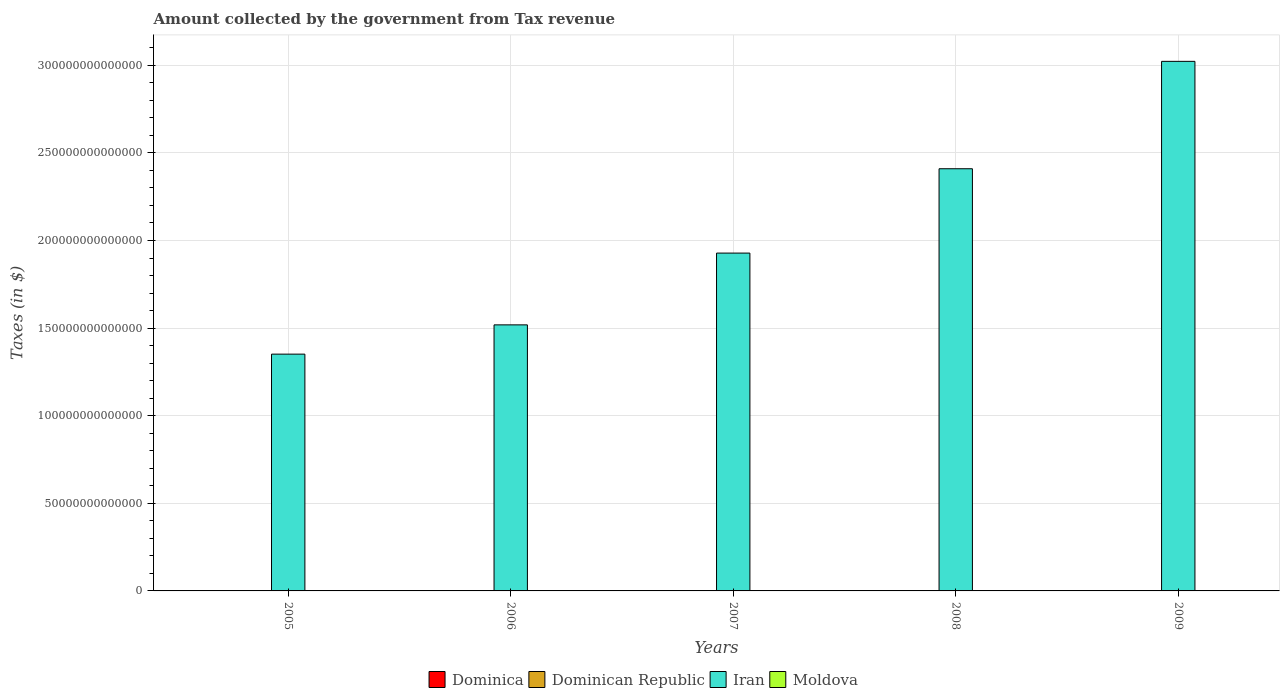How many different coloured bars are there?
Give a very brief answer. 4. Are the number of bars per tick equal to the number of legend labels?
Make the answer very short. Yes. How many bars are there on the 3rd tick from the left?
Offer a very short reply. 4. In how many cases, is the number of bars for a given year not equal to the number of legend labels?
Provide a succinct answer. 0. What is the amount collected by the government from tax revenue in Dominica in 2008?
Keep it short and to the point. 3.07e+08. Across all years, what is the maximum amount collected by the government from tax revenue in Dominica?
Provide a succinct answer. 3.21e+08. Across all years, what is the minimum amount collected by the government from tax revenue in Moldova?
Your answer should be very brief. 6.96e+09. In which year was the amount collected by the government from tax revenue in Dominica minimum?
Your answer should be compact. 2005. What is the total amount collected by the government from tax revenue in Dominica in the graph?
Your answer should be very brief. 1.39e+09. What is the difference between the amount collected by the government from tax revenue in Moldova in 2006 and that in 2007?
Offer a terse response. -2.23e+09. What is the difference between the amount collected by the government from tax revenue in Dominica in 2008 and the amount collected by the government from tax revenue in Moldova in 2009?
Provide a succinct answer. -1.04e+1. What is the average amount collected by the government from tax revenue in Dominica per year?
Give a very brief answer. 2.78e+08. In the year 2007, what is the difference between the amount collected by the government from tax revenue in Dominican Republic and amount collected by the government from tax revenue in Dominica?
Ensure brevity in your answer.  2.17e+11. In how many years, is the amount collected by the government from tax revenue in Moldova greater than 300000000000000 $?
Provide a short and direct response. 0. What is the ratio of the amount collected by the government from tax revenue in Dominican Republic in 2006 to that in 2009?
Your response must be concise. 0.8. What is the difference between the highest and the second highest amount collected by the government from tax revenue in Moldova?
Make the answer very short. 1.88e+09. What is the difference between the highest and the lowest amount collected by the government from tax revenue in Iran?
Offer a very short reply. 1.67e+14. What does the 4th bar from the left in 2008 represents?
Your answer should be compact. Moldova. What does the 3rd bar from the right in 2005 represents?
Offer a very short reply. Dominican Republic. How many bars are there?
Offer a very short reply. 20. What is the difference between two consecutive major ticks on the Y-axis?
Ensure brevity in your answer.  5.00e+13. Does the graph contain any zero values?
Ensure brevity in your answer.  No. Does the graph contain grids?
Give a very brief answer. Yes. Where does the legend appear in the graph?
Provide a succinct answer. Bottom center. What is the title of the graph?
Ensure brevity in your answer.  Amount collected by the government from Tax revenue. What is the label or title of the Y-axis?
Offer a very short reply. Taxes (in $). What is the Taxes (in $) in Dominica in 2005?
Your answer should be compact. 2.29e+08. What is the Taxes (in $) in Dominican Republic in 2005?
Provide a short and direct response. 1.48e+11. What is the Taxes (in $) in Iran in 2005?
Offer a terse response. 1.35e+14. What is the Taxes (in $) of Moldova in 2005?
Ensure brevity in your answer.  6.96e+09. What is the Taxes (in $) in Dominica in 2006?
Ensure brevity in your answer.  2.48e+08. What is the Taxes (in $) in Dominican Republic in 2006?
Keep it short and to the point. 1.77e+11. What is the Taxes (in $) in Iran in 2006?
Ensure brevity in your answer.  1.52e+14. What is the Taxes (in $) in Moldova in 2006?
Keep it short and to the point. 8.76e+09. What is the Taxes (in $) in Dominica in 2007?
Keep it short and to the point. 2.86e+08. What is the Taxes (in $) of Dominican Republic in 2007?
Offer a terse response. 2.17e+11. What is the Taxes (in $) in Iran in 2007?
Offer a very short reply. 1.93e+14. What is the Taxes (in $) of Moldova in 2007?
Offer a very short reply. 1.10e+1. What is the Taxes (in $) in Dominica in 2008?
Give a very brief answer. 3.07e+08. What is the Taxes (in $) of Dominican Republic in 2008?
Offer a very short reply. 2.35e+11. What is the Taxes (in $) in Iran in 2008?
Offer a very short reply. 2.41e+14. What is the Taxes (in $) of Moldova in 2008?
Offer a terse response. 1.29e+1. What is the Taxes (in $) in Dominica in 2009?
Keep it short and to the point. 3.21e+08. What is the Taxes (in $) in Dominican Republic in 2009?
Your answer should be compact. 2.19e+11. What is the Taxes (in $) of Iran in 2009?
Keep it short and to the point. 3.02e+14. What is the Taxes (in $) of Moldova in 2009?
Offer a terse response. 1.07e+1. Across all years, what is the maximum Taxes (in $) of Dominica?
Offer a terse response. 3.21e+08. Across all years, what is the maximum Taxes (in $) in Dominican Republic?
Ensure brevity in your answer.  2.35e+11. Across all years, what is the maximum Taxes (in $) in Iran?
Your answer should be very brief. 3.02e+14. Across all years, what is the maximum Taxes (in $) in Moldova?
Give a very brief answer. 1.29e+1. Across all years, what is the minimum Taxes (in $) of Dominica?
Your response must be concise. 2.29e+08. Across all years, what is the minimum Taxes (in $) of Dominican Republic?
Provide a succinct answer. 1.48e+11. Across all years, what is the minimum Taxes (in $) in Iran?
Offer a terse response. 1.35e+14. Across all years, what is the minimum Taxes (in $) in Moldova?
Your response must be concise. 6.96e+09. What is the total Taxes (in $) in Dominica in the graph?
Give a very brief answer. 1.39e+09. What is the total Taxes (in $) of Dominican Republic in the graph?
Provide a short and direct response. 9.97e+11. What is the total Taxes (in $) in Iran in the graph?
Offer a very short reply. 1.02e+15. What is the total Taxes (in $) of Moldova in the graph?
Offer a terse response. 5.03e+1. What is the difference between the Taxes (in $) of Dominica in 2005 and that in 2006?
Give a very brief answer. -1.86e+07. What is the difference between the Taxes (in $) in Dominican Republic in 2005 and that in 2006?
Ensure brevity in your answer.  -2.81e+1. What is the difference between the Taxes (in $) of Iran in 2005 and that in 2006?
Offer a terse response. -1.67e+13. What is the difference between the Taxes (in $) of Moldova in 2005 and that in 2006?
Offer a terse response. -1.80e+09. What is the difference between the Taxes (in $) of Dominica in 2005 and that in 2007?
Your answer should be very brief. -5.62e+07. What is the difference between the Taxes (in $) in Dominican Republic in 2005 and that in 2007?
Ensure brevity in your answer.  -6.87e+1. What is the difference between the Taxes (in $) of Iran in 2005 and that in 2007?
Give a very brief answer. -5.77e+13. What is the difference between the Taxes (in $) in Moldova in 2005 and that in 2007?
Your answer should be compact. -4.03e+09. What is the difference between the Taxes (in $) in Dominica in 2005 and that in 2008?
Your response must be concise. -7.81e+07. What is the difference between the Taxes (in $) in Dominican Republic in 2005 and that in 2008?
Provide a succinct answer. -8.69e+1. What is the difference between the Taxes (in $) of Iran in 2005 and that in 2008?
Give a very brief answer. -1.06e+14. What is the difference between the Taxes (in $) in Moldova in 2005 and that in 2008?
Provide a succinct answer. -5.90e+09. What is the difference between the Taxes (in $) in Dominica in 2005 and that in 2009?
Offer a terse response. -9.13e+07. What is the difference between the Taxes (in $) of Dominican Republic in 2005 and that in 2009?
Offer a very short reply. -7.10e+1. What is the difference between the Taxes (in $) of Iran in 2005 and that in 2009?
Offer a terse response. -1.67e+14. What is the difference between the Taxes (in $) in Moldova in 2005 and that in 2009?
Ensure brevity in your answer.  -3.73e+09. What is the difference between the Taxes (in $) of Dominica in 2006 and that in 2007?
Your response must be concise. -3.76e+07. What is the difference between the Taxes (in $) of Dominican Republic in 2006 and that in 2007?
Provide a succinct answer. -4.06e+1. What is the difference between the Taxes (in $) of Iran in 2006 and that in 2007?
Keep it short and to the point. -4.10e+13. What is the difference between the Taxes (in $) of Moldova in 2006 and that in 2007?
Your answer should be compact. -2.23e+09. What is the difference between the Taxes (in $) in Dominica in 2006 and that in 2008?
Provide a short and direct response. -5.95e+07. What is the difference between the Taxes (in $) in Dominican Republic in 2006 and that in 2008?
Your answer should be compact. -5.88e+1. What is the difference between the Taxes (in $) of Iran in 2006 and that in 2008?
Your answer should be very brief. -8.91e+13. What is the difference between the Taxes (in $) in Moldova in 2006 and that in 2008?
Your answer should be compact. -4.11e+09. What is the difference between the Taxes (in $) in Dominica in 2006 and that in 2009?
Your answer should be very brief. -7.27e+07. What is the difference between the Taxes (in $) in Dominican Republic in 2006 and that in 2009?
Make the answer very short. -4.28e+1. What is the difference between the Taxes (in $) of Iran in 2006 and that in 2009?
Your response must be concise. -1.50e+14. What is the difference between the Taxes (in $) in Moldova in 2006 and that in 2009?
Your answer should be very brief. -1.93e+09. What is the difference between the Taxes (in $) of Dominica in 2007 and that in 2008?
Offer a terse response. -2.19e+07. What is the difference between the Taxes (in $) in Dominican Republic in 2007 and that in 2008?
Provide a succinct answer. -1.82e+1. What is the difference between the Taxes (in $) in Iran in 2007 and that in 2008?
Your answer should be very brief. -4.81e+13. What is the difference between the Taxes (in $) in Moldova in 2007 and that in 2008?
Offer a terse response. -1.88e+09. What is the difference between the Taxes (in $) of Dominica in 2007 and that in 2009?
Give a very brief answer. -3.51e+07. What is the difference between the Taxes (in $) in Dominican Republic in 2007 and that in 2009?
Offer a very short reply. -2.26e+09. What is the difference between the Taxes (in $) of Iran in 2007 and that in 2009?
Provide a short and direct response. -1.09e+14. What is the difference between the Taxes (in $) in Moldova in 2007 and that in 2009?
Offer a terse response. 3.02e+08. What is the difference between the Taxes (in $) of Dominica in 2008 and that in 2009?
Keep it short and to the point. -1.32e+07. What is the difference between the Taxes (in $) of Dominican Republic in 2008 and that in 2009?
Your response must be concise. 1.59e+1. What is the difference between the Taxes (in $) of Iran in 2008 and that in 2009?
Keep it short and to the point. -6.13e+13. What is the difference between the Taxes (in $) of Moldova in 2008 and that in 2009?
Your answer should be very brief. 2.18e+09. What is the difference between the Taxes (in $) in Dominica in 2005 and the Taxes (in $) in Dominican Republic in 2006?
Offer a very short reply. -1.76e+11. What is the difference between the Taxes (in $) of Dominica in 2005 and the Taxes (in $) of Iran in 2006?
Keep it short and to the point. -1.52e+14. What is the difference between the Taxes (in $) of Dominica in 2005 and the Taxes (in $) of Moldova in 2006?
Keep it short and to the point. -8.53e+09. What is the difference between the Taxes (in $) of Dominican Republic in 2005 and the Taxes (in $) of Iran in 2006?
Provide a succinct answer. -1.52e+14. What is the difference between the Taxes (in $) in Dominican Republic in 2005 and the Taxes (in $) in Moldova in 2006?
Ensure brevity in your answer.  1.40e+11. What is the difference between the Taxes (in $) of Iran in 2005 and the Taxes (in $) of Moldova in 2006?
Your answer should be very brief. 1.35e+14. What is the difference between the Taxes (in $) in Dominica in 2005 and the Taxes (in $) in Dominican Republic in 2007?
Make the answer very short. -2.17e+11. What is the difference between the Taxes (in $) of Dominica in 2005 and the Taxes (in $) of Iran in 2007?
Your answer should be very brief. -1.93e+14. What is the difference between the Taxes (in $) of Dominica in 2005 and the Taxes (in $) of Moldova in 2007?
Provide a succinct answer. -1.08e+1. What is the difference between the Taxes (in $) of Dominican Republic in 2005 and the Taxes (in $) of Iran in 2007?
Your answer should be compact. -1.93e+14. What is the difference between the Taxes (in $) of Dominican Republic in 2005 and the Taxes (in $) of Moldova in 2007?
Offer a very short reply. 1.37e+11. What is the difference between the Taxes (in $) of Iran in 2005 and the Taxes (in $) of Moldova in 2007?
Ensure brevity in your answer.  1.35e+14. What is the difference between the Taxes (in $) of Dominica in 2005 and the Taxes (in $) of Dominican Republic in 2008?
Keep it short and to the point. -2.35e+11. What is the difference between the Taxes (in $) of Dominica in 2005 and the Taxes (in $) of Iran in 2008?
Your response must be concise. -2.41e+14. What is the difference between the Taxes (in $) in Dominica in 2005 and the Taxes (in $) in Moldova in 2008?
Your answer should be very brief. -1.26e+1. What is the difference between the Taxes (in $) in Dominican Republic in 2005 and the Taxes (in $) in Iran in 2008?
Your answer should be compact. -2.41e+14. What is the difference between the Taxes (in $) of Dominican Republic in 2005 and the Taxes (in $) of Moldova in 2008?
Your response must be concise. 1.36e+11. What is the difference between the Taxes (in $) of Iran in 2005 and the Taxes (in $) of Moldova in 2008?
Your answer should be compact. 1.35e+14. What is the difference between the Taxes (in $) of Dominica in 2005 and the Taxes (in $) of Dominican Republic in 2009?
Make the answer very short. -2.19e+11. What is the difference between the Taxes (in $) of Dominica in 2005 and the Taxes (in $) of Iran in 2009?
Give a very brief answer. -3.02e+14. What is the difference between the Taxes (in $) of Dominica in 2005 and the Taxes (in $) of Moldova in 2009?
Provide a short and direct response. -1.05e+1. What is the difference between the Taxes (in $) of Dominican Republic in 2005 and the Taxes (in $) of Iran in 2009?
Your answer should be compact. -3.02e+14. What is the difference between the Taxes (in $) of Dominican Republic in 2005 and the Taxes (in $) of Moldova in 2009?
Your answer should be very brief. 1.38e+11. What is the difference between the Taxes (in $) in Iran in 2005 and the Taxes (in $) in Moldova in 2009?
Make the answer very short. 1.35e+14. What is the difference between the Taxes (in $) of Dominica in 2006 and the Taxes (in $) of Dominican Republic in 2007?
Keep it short and to the point. -2.17e+11. What is the difference between the Taxes (in $) in Dominica in 2006 and the Taxes (in $) in Iran in 2007?
Offer a terse response. -1.93e+14. What is the difference between the Taxes (in $) in Dominica in 2006 and the Taxes (in $) in Moldova in 2007?
Offer a very short reply. -1.07e+1. What is the difference between the Taxes (in $) of Dominican Republic in 2006 and the Taxes (in $) of Iran in 2007?
Your response must be concise. -1.93e+14. What is the difference between the Taxes (in $) of Dominican Republic in 2006 and the Taxes (in $) of Moldova in 2007?
Provide a short and direct response. 1.66e+11. What is the difference between the Taxes (in $) of Iran in 2006 and the Taxes (in $) of Moldova in 2007?
Offer a terse response. 1.52e+14. What is the difference between the Taxes (in $) of Dominica in 2006 and the Taxes (in $) of Dominican Republic in 2008?
Provide a succinct answer. -2.35e+11. What is the difference between the Taxes (in $) of Dominica in 2006 and the Taxes (in $) of Iran in 2008?
Keep it short and to the point. -2.41e+14. What is the difference between the Taxes (in $) of Dominica in 2006 and the Taxes (in $) of Moldova in 2008?
Provide a succinct answer. -1.26e+1. What is the difference between the Taxes (in $) of Dominican Republic in 2006 and the Taxes (in $) of Iran in 2008?
Provide a succinct answer. -2.41e+14. What is the difference between the Taxes (in $) in Dominican Republic in 2006 and the Taxes (in $) in Moldova in 2008?
Keep it short and to the point. 1.64e+11. What is the difference between the Taxes (in $) of Iran in 2006 and the Taxes (in $) of Moldova in 2008?
Your answer should be compact. 1.52e+14. What is the difference between the Taxes (in $) of Dominica in 2006 and the Taxes (in $) of Dominican Republic in 2009?
Offer a terse response. -2.19e+11. What is the difference between the Taxes (in $) in Dominica in 2006 and the Taxes (in $) in Iran in 2009?
Make the answer very short. -3.02e+14. What is the difference between the Taxes (in $) of Dominica in 2006 and the Taxes (in $) of Moldova in 2009?
Your response must be concise. -1.04e+1. What is the difference between the Taxes (in $) in Dominican Republic in 2006 and the Taxes (in $) in Iran in 2009?
Offer a very short reply. -3.02e+14. What is the difference between the Taxes (in $) of Dominican Republic in 2006 and the Taxes (in $) of Moldova in 2009?
Provide a short and direct response. 1.66e+11. What is the difference between the Taxes (in $) in Iran in 2006 and the Taxes (in $) in Moldova in 2009?
Offer a very short reply. 1.52e+14. What is the difference between the Taxes (in $) of Dominica in 2007 and the Taxes (in $) of Dominican Republic in 2008?
Your answer should be very brief. -2.35e+11. What is the difference between the Taxes (in $) of Dominica in 2007 and the Taxes (in $) of Iran in 2008?
Give a very brief answer. -2.41e+14. What is the difference between the Taxes (in $) of Dominica in 2007 and the Taxes (in $) of Moldova in 2008?
Provide a succinct answer. -1.26e+1. What is the difference between the Taxes (in $) of Dominican Republic in 2007 and the Taxes (in $) of Iran in 2008?
Provide a succinct answer. -2.41e+14. What is the difference between the Taxes (in $) in Dominican Republic in 2007 and the Taxes (in $) in Moldova in 2008?
Offer a very short reply. 2.04e+11. What is the difference between the Taxes (in $) of Iran in 2007 and the Taxes (in $) of Moldova in 2008?
Ensure brevity in your answer.  1.93e+14. What is the difference between the Taxes (in $) of Dominica in 2007 and the Taxes (in $) of Dominican Republic in 2009?
Keep it short and to the point. -2.19e+11. What is the difference between the Taxes (in $) in Dominica in 2007 and the Taxes (in $) in Iran in 2009?
Offer a terse response. -3.02e+14. What is the difference between the Taxes (in $) in Dominica in 2007 and the Taxes (in $) in Moldova in 2009?
Offer a terse response. -1.04e+1. What is the difference between the Taxes (in $) in Dominican Republic in 2007 and the Taxes (in $) in Iran in 2009?
Offer a very short reply. -3.02e+14. What is the difference between the Taxes (in $) in Dominican Republic in 2007 and the Taxes (in $) in Moldova in 2009?
Keep it short and to the point. 2.06e+11. What is the difference between the Taxes (in $) of Iran in 2007 and the Taxes (in $) of Moldova in 2009?
Your response must be concise. 1.93e+14. What is the difference between the Taxes (in $) in Dominica in 2008 and the Taxes (in $) in Dominican Republic in 2009?
Provide a succinct answer. -2.19e+11. What is the difference between the Taxes (in $) in Dominica in 2008 and the Taxes (in $) in Iran in 2009?
Ensure brevity in your answer.  -3.02e+14. What is the difference between the Taxes (in $) in Dominica in 2008 and the Taxes (in $) in Moldova in 2009?
Offer a very short reply. -1.04e+1. What is the difference between the Taxes (in $) of Dominican Republic in 2008 and the Taxes (in $) of Iran in 2009?
Provide a succinct answer. -3.02e+14. What is the difference between the Taxes (in $) in Dominican Republic in 2008 and the Taxes (in $) in Moldova in 2009?
Your answer should be compact. 2.25e+11. What is the difference between the Taxes (in $) in Iran in 2008 and the Taxes (in $) in Moldova in 2009?
Ensure brevity in your answer.  2.41e+14. What is the average Taxes (in $) of Dominica per year?
Give a very brief answer. 2.78e+08. What is the average Taxes (in $) in Dominican Republic per year?
Keep it short and to the point. 1.99e+11. What is the average Taxes (in $) of Iran per year?
Make the answer very short. 2.05e+14. What is the average Taxes (in $) in Moldova per year?
Provide a short and direct response. 1.01e+1. In the year 2005, what is the difference between the Taxes (in $) in Dominica and Taxes (in $) in Dominican Republic?
Give a very brief answer. -1.48e+11. In the year 2005, what is the difference between the Taxes (in $) in Dominica and Taxes (in $) in Iran?
Your answer should be very brief. -1.35e+14. In the year 2005, what is the difference between the Taxes (in $) of Dominica and Taxes (in $) of Moldova?
Offer a terse response. -6.73e+09. In the year 2005, what is the difference between the Taxes (in $) of Dominican Republic and Taxes (in $) of Iran?
Offer a very short reply. -1.35e+14. In the year 2005, what is the difference between the Taxes (in $) of Dominican Republic and Taxes (in $) of Moldova?
Provide a succinct answer. 1.41e+11. In the year 2005, what is the difference between the Taxes (in $) of Iran and Taxes (in $) of Moldova?
Keep it short and to the point. 1.35e+14. In the year 2006, what is the difference between the Taxes (in $) in Dominica and Taxes (in $) in Dominican Republic?
Your response must be concise. -1.76e+11. In the year 2006, what is the difference between the Taxes (in $) of Dominica and Taxes (in $) of Iran?
Provide a short and direct response. -1.52e+14. In the year 2006, what is the difference between the Taxes (in $) of Dominica and Taxes (in $) of Moldova?
Your answer should be compact. -8.51e+09. In the year 2006, what is the difference between the Taxes (in $) in Dominican Republic and Taxes (in $) in Iran?
Give a very brief answer. -1.52e+14. In the year 2006, what is the difference between the Taxes (in $) in Dominican Republic and Taxes (in $) in Moldova?
Your answer should be compact. 1.68e+11. In the year 2006, what is the difference between the Taxes (in $) in Iran and Taxes (in $) in Moldova?
Your answer should be very brief. 1.52e+14. In the year 2007, what is the difference between the Taxes (in $) of Dominica and Taxes (in $) of Dominican Republic?
Give a very brief answer. -2.17e+11. In the year 2007, what is the difference between the Taxes (in $) in Dominica and Taxes (in $) in Iran?
Make the answer very short. -1.93e+14. In the year 2007, what is the difference between the Taxes (in $) in Dominica and Taxes (in $) in Moldova?
Make the answer very short. -1.07e+1. In the year 2007, what is the difference between the Taxes (in $) in Dominican Republic and Taxes (in $) in Iran?
Offer a very short reply. -1.93e+14. In the year 2007, what is the difference between the Taxes (in $) in Dominican Republic and Taxes (in $) in Moldova?
Provide a succinct answer. 2.06e+11. In the year 2007, what is the difference between the Taxes (in $) of Iran and Taxes (in $) of Moldova?
Offer a terse response. 1.93e+14. In the year 2008, what is the difference between the Taxes (in $) of Dominica and Taxes (in $) of Dominican Republic?
Provide a succinct answer. -2.35e+11. In the year 2008, what is the difference between the Taxes (in $) in Dominica and Taxes (in $) in Iran?
Your answer should be very brief. -2.41e+14. In the year 2008, what is the difference between the Taxes (in $) of Dominica and Taxes (in $) of Moldova?
Your answer should be compact. -1.26e+1. In the year 2008, what is the difference between the Taxes (in $) in Dominican Republic and Taxes (in $) in Iran?
Offer a very short reply. -2.41e+14. In the year 2008, what is the difference between the Taxes (in $) in Dominican Republic and Taxes (in $) in Moldova?
Provide a succinct answer. 2.22e+11. In the year 2008, what is the difference between the Taxes (in $) in Iran and Taxes (in $) in Moldova?
Make the answer very short. 2.41e+14. In the year 2009, what is the difference between the Taxes (in $) of Dominica and Taxes (in $) of Dominican Republic?
Keep it short and to the point. -2.19e+11. In the year 2009, what is the difference between the Taxes (in $) in Dominica and Taxes (in $) in Iran?
Offer a terse response. -3.02e+14. In the year 2009, what is the difference between the Taxes (in $) in Dominica and Taxes (in $) in Moldova?
Provide a short and direct response. -1.04e+1. In the year 2009, what is the difference between the Taxes (in $) in Dominican Republic and Taxes (in $) in Iran?
Your response must be concise. -3.02e+14. In the year 2009, what is the difference between the Taxes (in $) of Dominican Republic and Taxes (in $) of Moldova?
Ensure brevity in your answer.  2.09e+11. In the year 2009, what is the difference between the Taxes (in $) of Iran and Taxes (in $) of Moldova?
Provide a succinct answer. 3.02e+14. What is the ratio of the Taxes (in $) in Dominica in 2005 to that in 2006?
Your answer should be very brief. 0.93. What is the ratio of the Taxes (in $) of Dominican Republic in 2005 to that in 2006?
Your answer should be compact. 0.84. What is the ratio of the Taxes (in $) in Iran in 2005 to that in 2006?
Offer a terse response. 0.89. What is the ratio of the Taxes (in $) in Moldova in 2005 to that in 2006?
Make the answer very short. 0.79. What is the ratio of the Taxes (in $) in Dominica in 2005 to that in 2007?
Offer a terse response. 0.8. What is the ratio of the Taxes (in $) of Dominican Republic in 2005 to that in 2007?
Keep it short and to the point. 0.68. What is the ratio of the Taxes (in $) of Iran in 2005 to that in 2007?
Your answer should be very brief. 0.7. What is the ratio of the Taxes (in $) in Moldova in 2005 to that in 2007?
Ensure brevity in your answer.  0.63. What is the ratio of the Taxes (in $) of Dominica in 2005 to that in 2008?
Provide a short and direct response. 0.75. What is the ratio of the Taxes (in $) of Dominican Republic in 2005 to that in 2008?
Make the answer very short. 0.63. What is the ratio of the Taxes (in $) in Iran in 2005 to that in 2008?
Ensure brevity in your answer.  0.56. What is the ratio of the Taxes (in $) of Moldova in 2005 to that in 2008?
Provide a succinct answer. 0.54. What is the ratio of the Taxes (in $) of Dominica in 2005 to that in 2009?
Offer a terse response. 0.72. What is the ratio of the Taxes (in $) in Dominican Republic in 2005 to that in 2009?
Your answer should be compact. 0.68. What is the ratio of the Taxes (in $) in Iran in 2005 to that in 2009?
Your answer should be compact. 0.45. What is the ratio of the Taxes (in $) of Moldova in 2005 to that in 2009?
Keep it short and to the point. 0.65. What is the ratio of the Taxes (in $) in Dominica in 2006 to that in 2007?
Offer a very short reply. 0.87. What is the ratio of the Taxes (in $) of Dominican Republic in 2006 to that in 2007?
Your response must be concise. 0.81. What is the ratio of the Taxes (in $) in Iran in 2006 to that in 2007?
Provide a succinct answer. 0.79. What is the ratio of the Taxes (in $) of Moldova in 2006 to that in 2007?
Ensure brevity in your answer.  0.8. What is the ratio of the Taxes (in $) in Dominica in 2006 to that in 2008?
Provide a succinct answer. 0.81. What is the ratio of the Taxes (in $) of Dominican Republic in 2006 to that in 2008?
Your answer should be compact. 0.75. What is the ratio of the Taxes (in $) in Iran in 2006 to that in 2008?
Make the answer very short. 0.63. What is the ratio of the Taxes (in $) in Moldova in 2006 to that in 2008?
Offer a very short reply. 0.68. What is the ratio of the Taxes (in $) in Dominica in 2006 to that in 2009?
Offer a terse response. 0.77. What is the ratio of the Taxes (in $) in Dominican Republic in 2006 to that in 2009?
Your answer should be very brief. 0.8. What is the ratio of the Taxes (in $) of Iran in 2006 to that in 2009?
Provide a short and direct response. 0.5. What is the ratio of the Taxes (in $) in Moldova in 2006 to that in 2009?
Your answer should be very brief. 0.82. What is the ratio of the Taxes (in $) in Dominica in 2007 to that in 2008?
Keep it short and to the point. 0.93. What is the ratio of the Taxes (in $) in Dominican Republic in 2007 to that in 2008?
Keep it short and to the point. 0.92. What is the ratio of the Taxes (in $) in Iran in 2007 to that in 2008?
Keep it short and to the point. 0.8. What is the ratio of the Taxes (in $) in Moldova in 2007 to that in 2008?
Make the answer very short. 0.85. What is the ratio of the Taxes (in $) of Dominica in 2007 to that in 2009?
Ensure brevity in your answer.  0.89. What is the ratio of the Taxes (in $) of Dominican Republic in 2007 to that in 2009?
Give a very brief answer. 0.99. What is the ratio of the Taxes (in $) in Iran in 2007 to that in 2009?
Provide a succinct answer. 0.64. What is the ratio of the Taxes (in $) in Moldova in 2007 to that in 2009?
Offer a terse response. 1.03. What is the ratio of the Taxes (in $) of Dominica in 2008 to that in 2009?
Your answer should be compact. 0.96. What is the ratio of the Taxes (in $) of Dominican Republic in 2008 to that in 2009?
Offer a terse response. 1.07. What is the ratio of the Taxes (in $) in Iran in 2008 to that in 2009?
Your response must be concise. 0.8. What is the ratio of the Taxes (in $) of Moldova in 2008 to that in 2009?
Offer a very short reply. 1.2. What is the difference between the highest and the second highest Taxes (in $) of Dominica?
Keep it short and to the point. 1.32e+07. What is the difference between the highest and the second highest Taxes (in $) of Dominican Republic?
Offer a very short reply. 1.59e+1. What is the difference between the highest and the second highest Taxes (in $) of Iran?
Provide a short and direct response. 6.13e+13. What is the difference between the highest and the second highest Taxes (in $) of Moldova?
Provide a succinct answer. 1.88e+09. What is the difference between the highest and the lowest Taxes (in $) in Dominica?
Your response must be concise. 9.13e+07. What is the difference between the highest and the lowest Taxes (in $) in Dominican Republic?
Your answer should be compact. 8.69e+1. What is the difference between the highest and the lowest Taxes (in $) in Iran?
Your answer should be very brief. 1.67e+14. What is the difference between the highest and the lowest Taxes (in $) in Moldova?
Offer a terse response. 5.90e+09. 